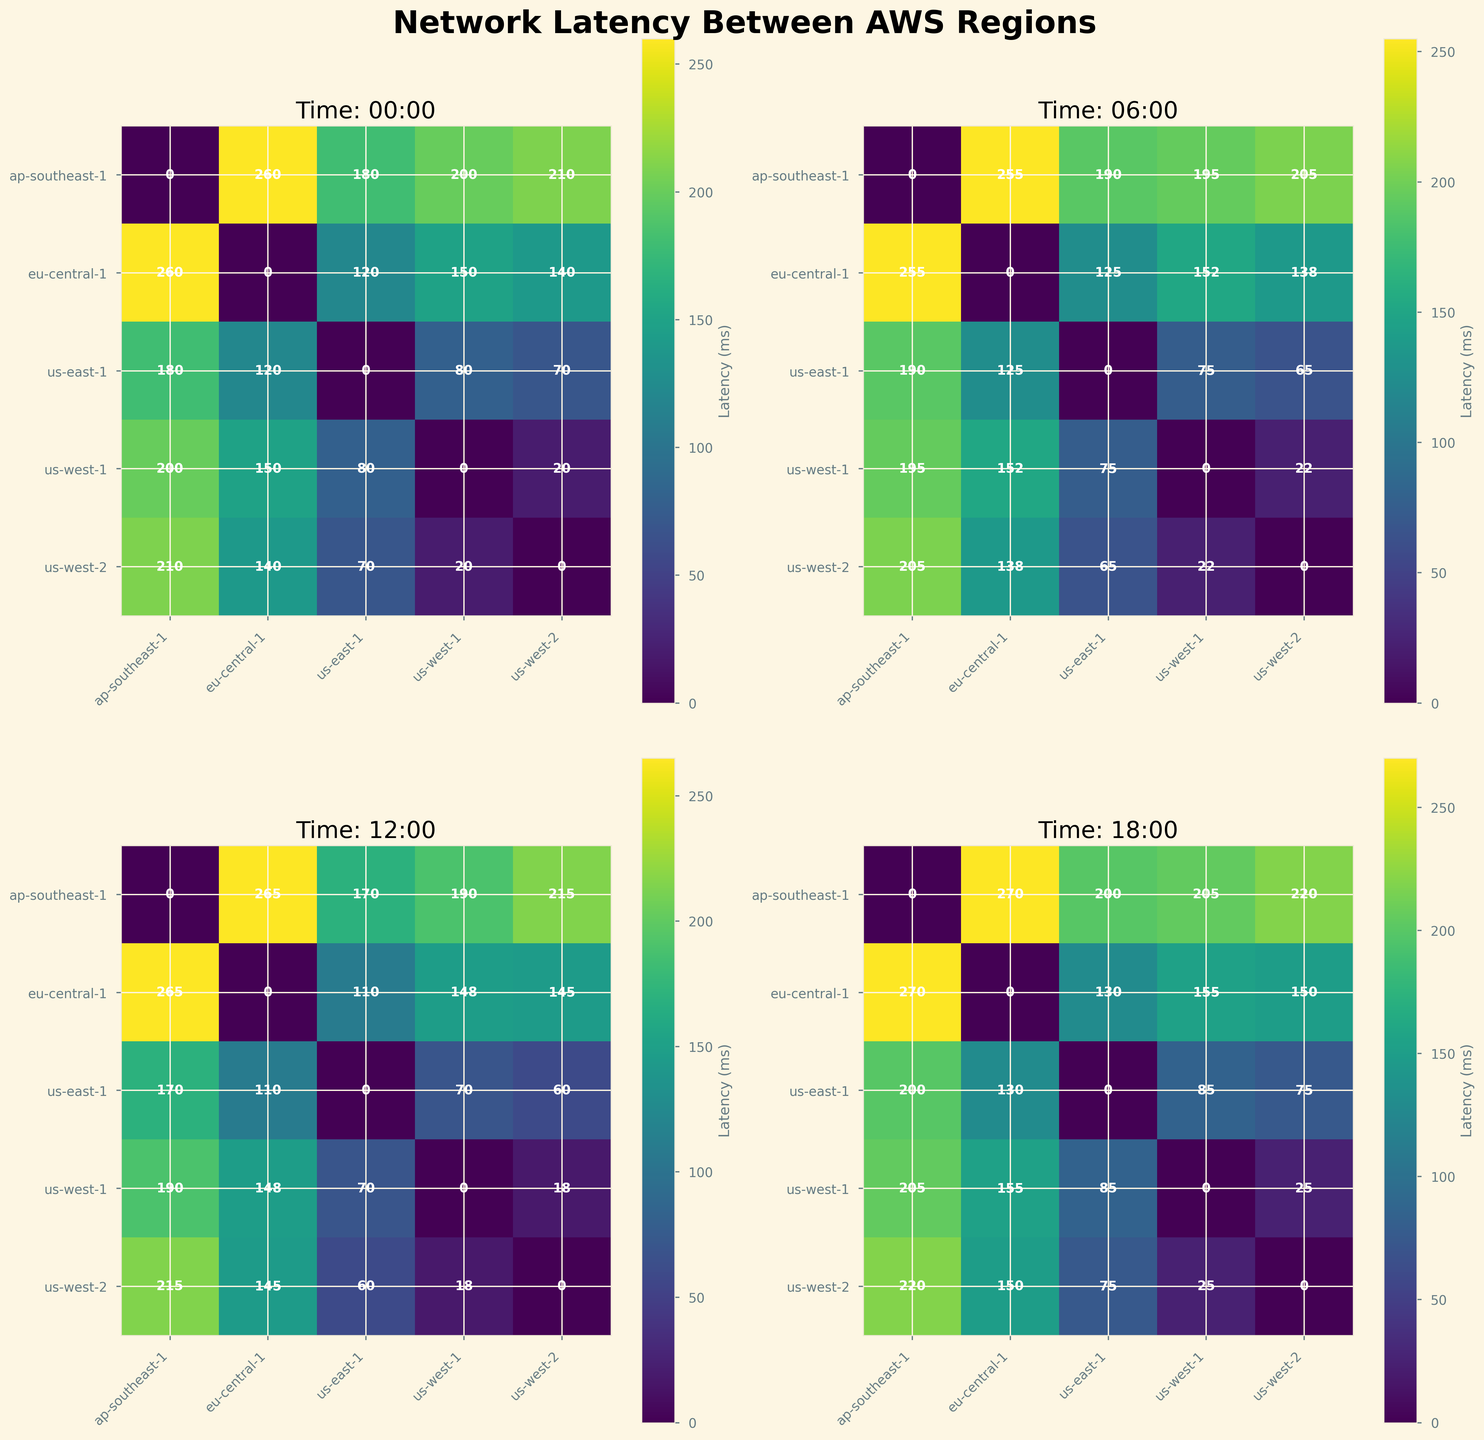How many regions are compared for latency in the figure? The figure represents latencies between multiple AWS regions. By observing the axes labels, you can count the distinct regions listed along the x-axis and y-axis, which are 'us-east-1', 'us-west-1', 'us-west-2', 'eu-central-1', and 'ap-southeast-1', summing up to 5 regions.
Answer: 5 Which pair of regions has the highest latency at 18:00? Look at the time-specific subplot for 18:00. Among the different region pairs, the color corresponding to the maximum range in the colormap (likely to be near yellow or white given the 'viridis' color scheme) denotes the highest latency value. The pair 'eu-central-1' and 'ap-southeast-1' shows the highest latency of 270 ms, indicated by the lightest color.
Answer: eu-central-1 and ap-southeast-1 What is the latency between 'us-east-1' and 'eu-central-1' at 12:00? In the subplot for 12:00, locate the intersection of the 'us-east-1' row and the 'eu-central-1' column. The number displayed at this intersection point shows the latency value, which is 110 ms.
Answer: 110 ms At which time is the latency between 'us-west-2' and 'ap-southeast-1' the lowest? Compare the latency values for 'us-west-2' and 'ap-southeast-1' across all the subplots. The values are 210 ms at 00:00, 205 ms at 06:00, 215 ms at 12:00, and 220 ms at 18:00. The lowest latency is 205 ms, found at 06:00.
Answer: 06:00 How does the latency between 'us-west-1' and 'us-west-2' change over time? Examine the latency values between 'us-west-1' and 'us-west-2' across the subplots for each time. The values are 20 ms at 00:00, 22 ms at 06:00, 18 ms at 12:00, and 25 ms at 18:00. The latency slightly increases from 00:00 to 06:00, decreases at 12:00, and increases again at 18:00.
Answer: Fluctuates slightly Which time shows the lowest overall latency for the majority of region pairs? Review each subplot and observe the overall color tones and numbers. Identify which time-specific subplot contains the most instances of lower latency values (darker colors). For most region pairs, 12:00 shows relatively lower latency values compared to other times.
Answer: 12:00 Compare the latencies between 'us-east-1' and 'ap-southeast-1' at 00:00 and 12:00. Which is higher? Find the latency values for the pair 'us-east-1' and 'ap-southeast-1' in the subplots for 00:00 and 12:00. The values are 180 ms at 00:00 and 170 ms at 12:00. Therefore, the latency is higher at 00:00.
Answer: 00:00 